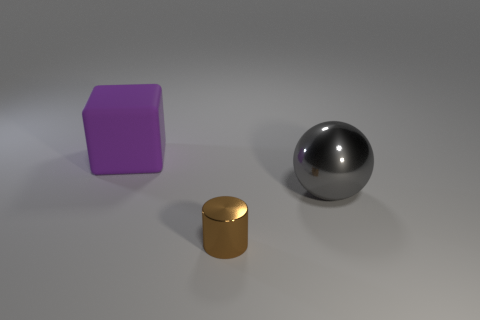The thing that is made of the same material as the large gray sphere is what shape?
Offer a very short reply. Cylinder. What material is the large gray object?
Make the answer very short. Metal. How many objects are either matte blocks or tiny brown metal things?
Offer a very short reply. 2. What size is the thing behind the large metal object?
Make the answer very short. Large. How many other objects are the same material as the big purple block?
Give a very brief answer. 0. Is there a tiny brown metal object in front of the big thing that is right of the small shiny object?
Make the answer very short. Yes. Are there any other things that are the same shape as the purple thing?
Your answer should be compact. No. What size is the purple object?
Provide a short and direct response. Large. Are there fewer brown things behind the purple rubber thing than tiny gray rubber balls?
Your answer should be very brief. No. Are the big gray object and the object in front of the large shiny object made of the same material?
Your response must be concise. Yes. 